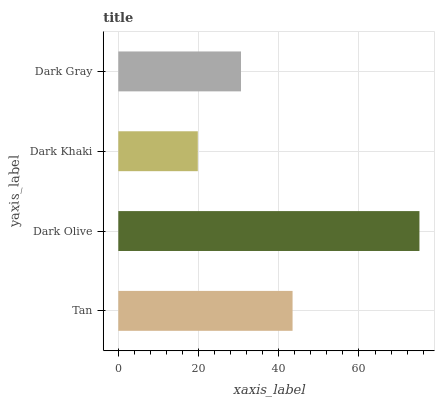Is Dark Khaki the minimum?
Answer yes or no. Yes. Is Dark Olive the maximum?
Answer yes or no. Yes. Is Dark Olive the minimum?
Answer yes or no. No. Is Dark Khaki the maximum?
Answer yes or no. No. Is Dark Olive greater than Dark Khaki?
Answer yes or no. Yes. Is Dark Khaki less than Dark Olive?
Answer yes or no. Yes. Is Dark Khaki greater than Dark Olive?
Answer yes or no. No. Is Dark Olive less than Dark Khaki?
Answer yes or no. No. Is Tan the high median?
Answer yes or no. Yes. Is Dark Gray the low median?
Answer yes or no. Yes. Is Dark Olive the high median?
Answer yes or no. No. Is Tan the low median?
Answer yes or no. No. 